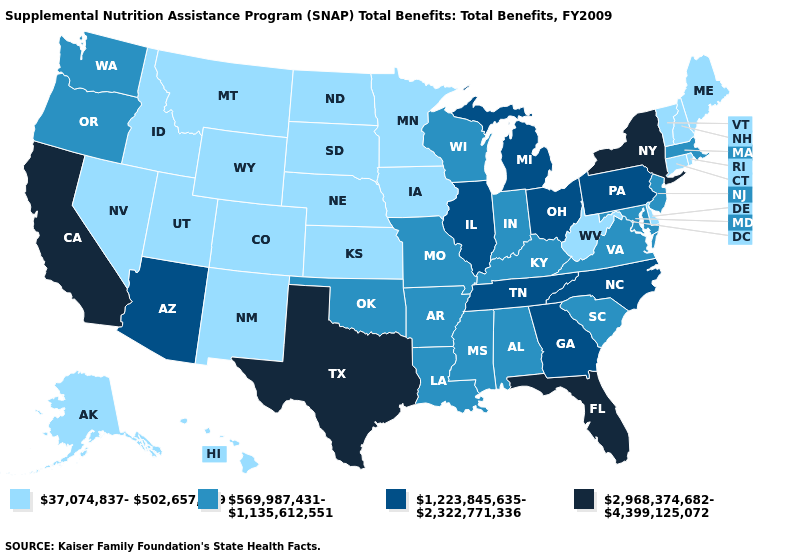What is the value of Louisiana?
Short answer required. 569,987,431-1,135,612,551. Which states have the lowest value in the West?
Keep it brief. Alaska, Colorado, Hawaii, Idaho, Montana, Nevada, New Mexico, Utah, Wyoming. Name the states that have a value in the range 569,987,431-1,135,612,551?
Concise answer only. Alabama, Arkansas, Indiana, Kentucky, Louisiana, Maryland, Massachusetts, Mississippi, Missouri, New Jersey, Oklahoma, Oregon, South Carolina, Virginia, Washington, Wisconsin. Name the states that have a value in the range 569,987,431-1,135,612,551?
Answer briefly. Alabama, Arkansas, Indiana, Kentucky, Louisiana, Maryland, Massachusetts, Mississippi, Missouri, New Jersey, Oklahoma, Oregon, South Carolina, Virginia, Washington, Wisconsin. Which states hav the highest value in the South?
Concise answer only. Florida, Texas. Name the states that have a value in the range 569,987,431-1,135,612,551?
Quick response, please. Alabama, Arkansas, Indiana, Kentucky, Louisiana, Maryland, Massachusetts, Mississippi, Missouri, New Jersey, Oklahoma, Oregon, South Carolina, Virginia, Washington, Wisconsin. Which states have the highest value in the USA?
Be succinct. California, Florida, New York, Texas. Does Michigan have the highest value in the MidWest?
Answer briefly. Yes. Name the states that have a value in the range 569,987,431-1,135,612,551?
Write a very short answer. Alabama, Arkansas, Indiana, Kentucky, Louisiana, Maryland, Massachusetts, Mississippi, Missouri, New Jersey, Oklahoma, Oregon, South Carolina, Virginia, Washington, Wisconsin. Does Colorado have a lower value than Montana?
Write a very short answer. No. Which states have the lowest value in the USA?
Give a very brief answer. Alaska, Colorado, Connecticut, Delaware, Hawaii, Idaho, Iowa, Kansas, Maine, Minnesota, Montana, Nebraska, Nevada, New Hampshire, New Mexico, North Dakota, Rhode Island, South Dakota, Utah, Vermont, West Virginia, Wyoming. Does Arizona have a higher value than Florida?
Give a very brief answer. No. What is the lowest value in the South?
Keep it brief. 37,074,837-502,657,149. Name the states that have a value in the range 1,223,845,635-2,322,771,336?
Short answer required. Arizona, Georgia, Illinois, Michigan, North Carolina, Ohio, Pennsylvania, Tennessee. What is the lowest value in the USA?
Keep it brief. 37,074,837-502,657,149. 